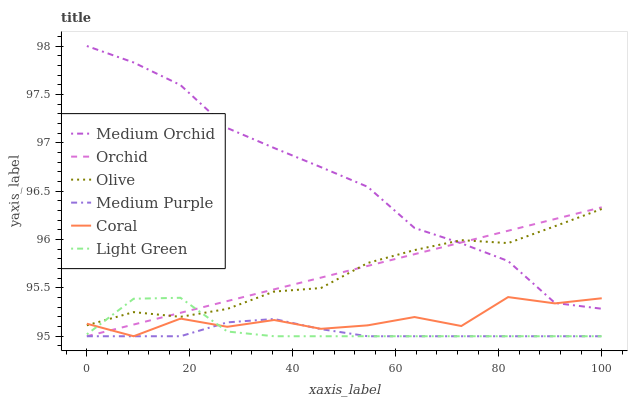Does Medium Purple have the minimum area under the curve?
Answer yes or no. Yes. Does Medium Orchid have the maximum area under the curve?
Answer yes or no. Yes. Does Medium Orchid have the minimum area under the curve?
Answer yes or no. No. Does Medium Purple have the maximum area under the curve?
Answer yes or no. No. Is Orchid the smoothest?
Answer yes or no. Yes. Is Coral the roughest?
Answer yes or no. Yes. Is Medium Orchid the smoothest?
Answer yes or no. No. Is Medium Orchid the roughest?
Answer yes or no. No. Does Coral have the lowest value?
Answer yes or no. Yes. Does Medium Orchid have the lowest value?
Answer yes or no. No. Does Medium Orchid have the highest value?
Answer yes or no. Yes. Does Medium Purple have the highest value?
Answer yes or no. No. Is Medium Purple less than Medium Orchid?
Answer yes or no. Yes. Is Medium Orchid greater than Light Green?
Answer yes or no. Yes. Does Coral intersect Medium Purple?
Answer yes or no. Yes. Is Coral less than Medium Purple?
Answer yes or no. No. Is Coral greater than Medium Purple?
Answer yes or no. No. Does Medium Purple intersect Medium Orchid?
Answer yes or no. No. 